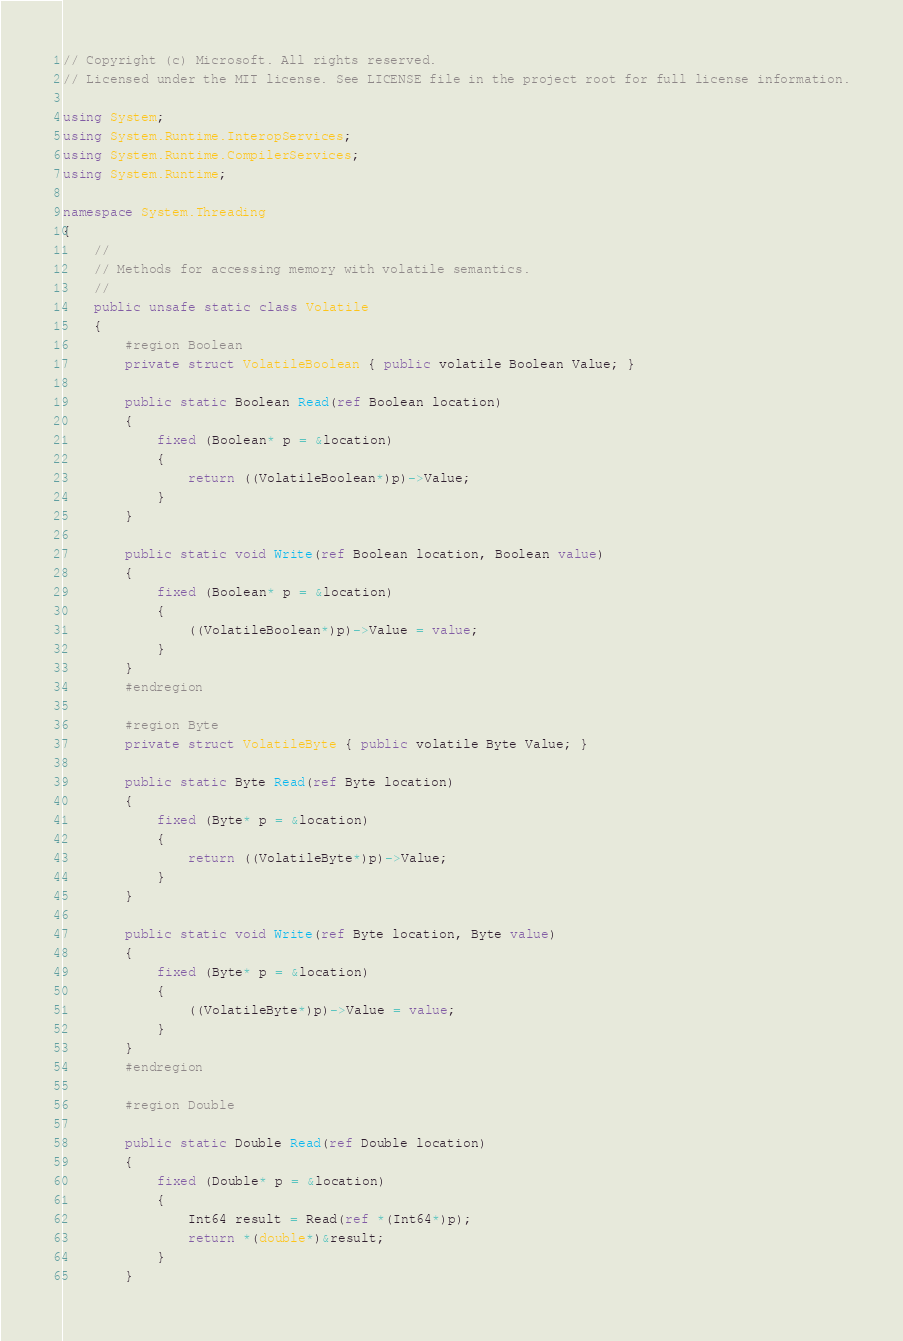Convert code to text. <code><loc_0><loc_0><loc_500><loc_500><_C#_>// Copyright (c) Microsoft. All rights reserved.
// Licensed under the MIT license. See LICENSE file in the project root for full license information.

using System;
using System.Runtime.InteropServices;
using System.Runtime.CompilerServices;
using System.Runtime;

namespace System.Threading
{
    //
    // Methods for accessing memory with volatile semantics.
    //
    public unsafe static class Volatile
    {
        #region Boolean
        private struct VolatileBoolean { public volatile Boolean Value; }

        public static Boolean Read(ref Boolean location)
        {
            fixed (Boolean* p = &location)
            {
                return ((VolatileBoolean*)p)->Value;
            }
        }

        public static void Write(ref Boolean location, Boolean value)
        {
            fixed (Boolean* p = &location)
            {
                ((VolatileBoolean*)p)->Value = value;
            }
        }
        #endregion

        #region Byte
        private struct VolatileByte { public volatile Byte Value; }

        public static Byte Read(ref Byte location)
        {
            fixed (Byte* p = &location)
            {
                return ((VolatileByte*)p)->Value;
            }
        }

        public static void Write(ref Byte location, Byte value)
        {
            fixed (Byte* p = &location)
            {
                ((VolatileByte*)p)->Value = value;
            }
        }
        #endregion

        #region Double

        public static Double Read(ref Double location)
        {
            fixed (Double* p = &location)
            {
                Int64 result = Read(ref *(Int64*)p);
                return *(double*)&result;
            }
        }
</code> 